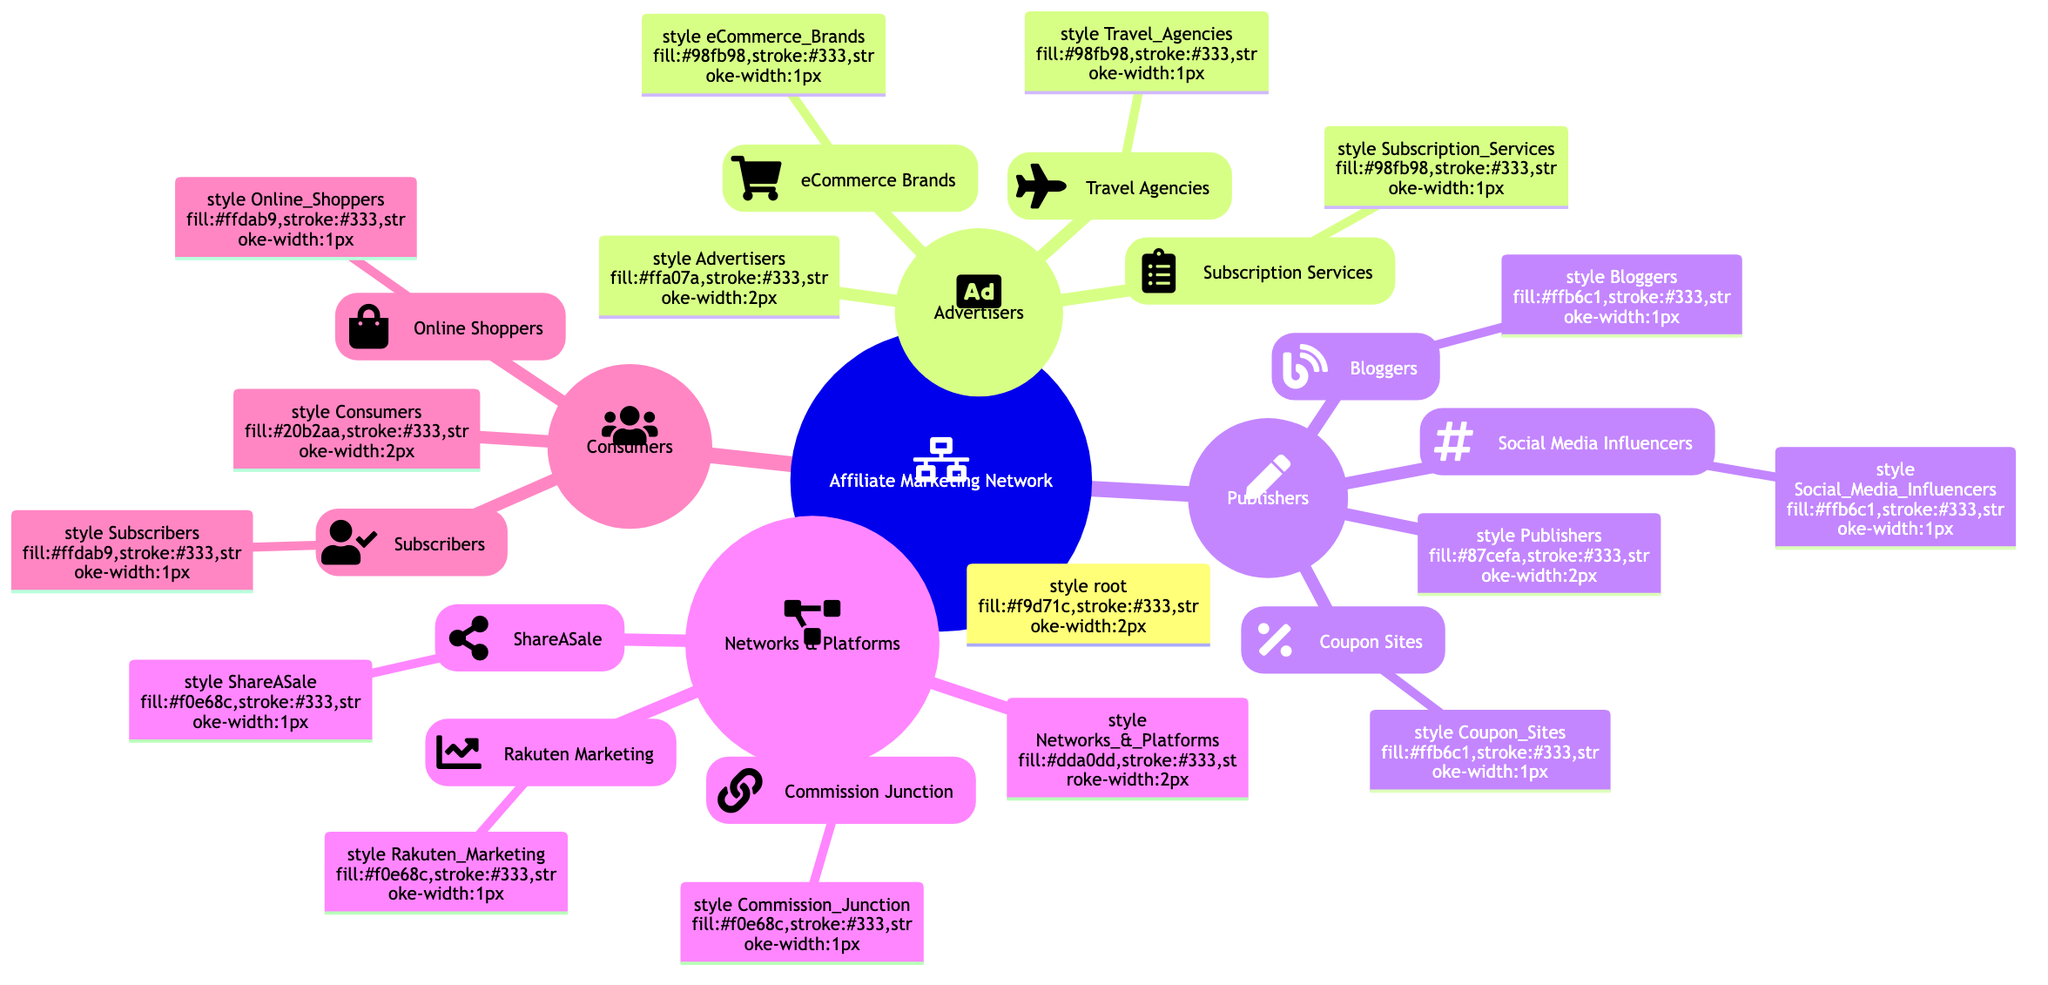What are the main categories in the Affiliate Marketing Network? The diagram shows four main categories: Advertisers, Publishers, Networks & Platforms, and Consumers. These nodes represent the primary entities involved in affiliate marketing.
Answer: Advertisers, Publishers, Networks & Platforms, Consumers How many children does the Publishers category have? The Publishers category has three children: Bloggers, Social Media Influencers, and Coupon Sites. By counting these nodes, we find there are three direct subcategories under Publishers.
Answer: 3 What type of contribution do eCommerce Brands provide? According to the diagram, eCommerce Brands provide products and services for promotion, which specifies their role within the Advertisers category.
Answer: Provide products and services for promotion Which group connects advertisers with publishers? The group that connects advertisers with publishers is Commission Junction, which is listed under Networks & Platforms. This is a key role of that entity in the affiliate marketing network.
Answer: Commission Junction What is the total number of children under the Consumers category? The Consumers category includes two children: Online Shoppers and Subscribers. Adding these two nodes gives us the total number of children under Consumers.
Answer: 2 Who are the contributors promoting products through social channels? Social Media Influencers are the contributors in this network who promote products through their social channels, as stated in the Publishers category.
Answer: Social Media Influencers What type of contribution do Coupon Sites provide? Coupon Sites contribute by sharing discount codes and offers, which is outlined in their description under the Publishers category.
Answer: Share discount codes and offers Which category does Rakuten Marketing belong to? Rakuten Marketing belongs to the Networks & Platforms category, as indicated in its respective node in the diagram that delineates its roles in the affiliate marketing network.
Answer: Networks & Platforms What category offers commissions on new subscriptions? The category that offers commissions on new subscriptions is Subscription Services, found within the Advertisers category. This contribution is specific to Subscription Services.
Answer: Subscription Services 